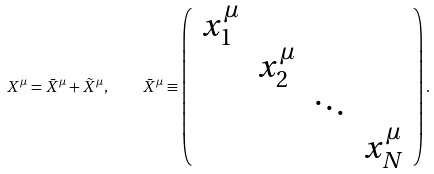Convert formula to latex. <formula><loc_0><loc_0><loc_500><loc_500>X ^ { \mu } = \bar { X } ^ { \mu } + \tilde { X } ^ { \mu } , \quad \bar { X } ^ { \mu } \equiv \left ( \begin{array} { l l l l } x _ { 1 } ^ { \mu } & & & \\ & x _ { 2 } ^ { \mu } & & \\ & & \ddots & \\ & & & x _ { N } ^ { \mu } \end{array} \right ) .</formula> 